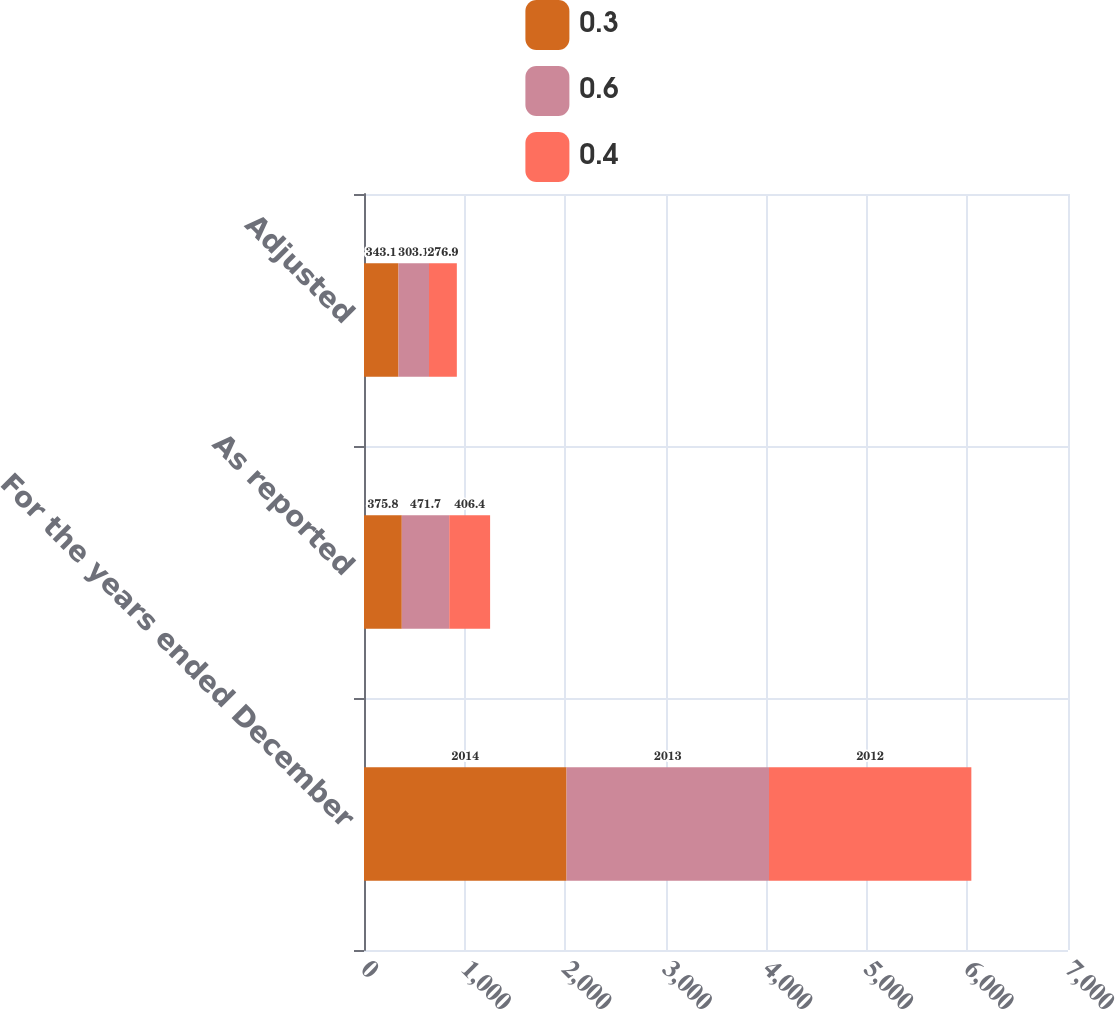Convert chart to OTSL. <chart><loc_0><loc_0><loc_500><loc_500><stacked_bar_chart><ecel><fcel>For the years ended December<fcel>As reported<fcel>Adjusted<nl><fcel>0.3<fcel>2014<fcel>375.8<fcel>343.1<nl><fcel>0.6<fcel>2013<fcel>471.7<fcel>303.1<nl><fcel>0.4<fcel>2012<fcel>406.4<fcel>276.9<nl></chart> 